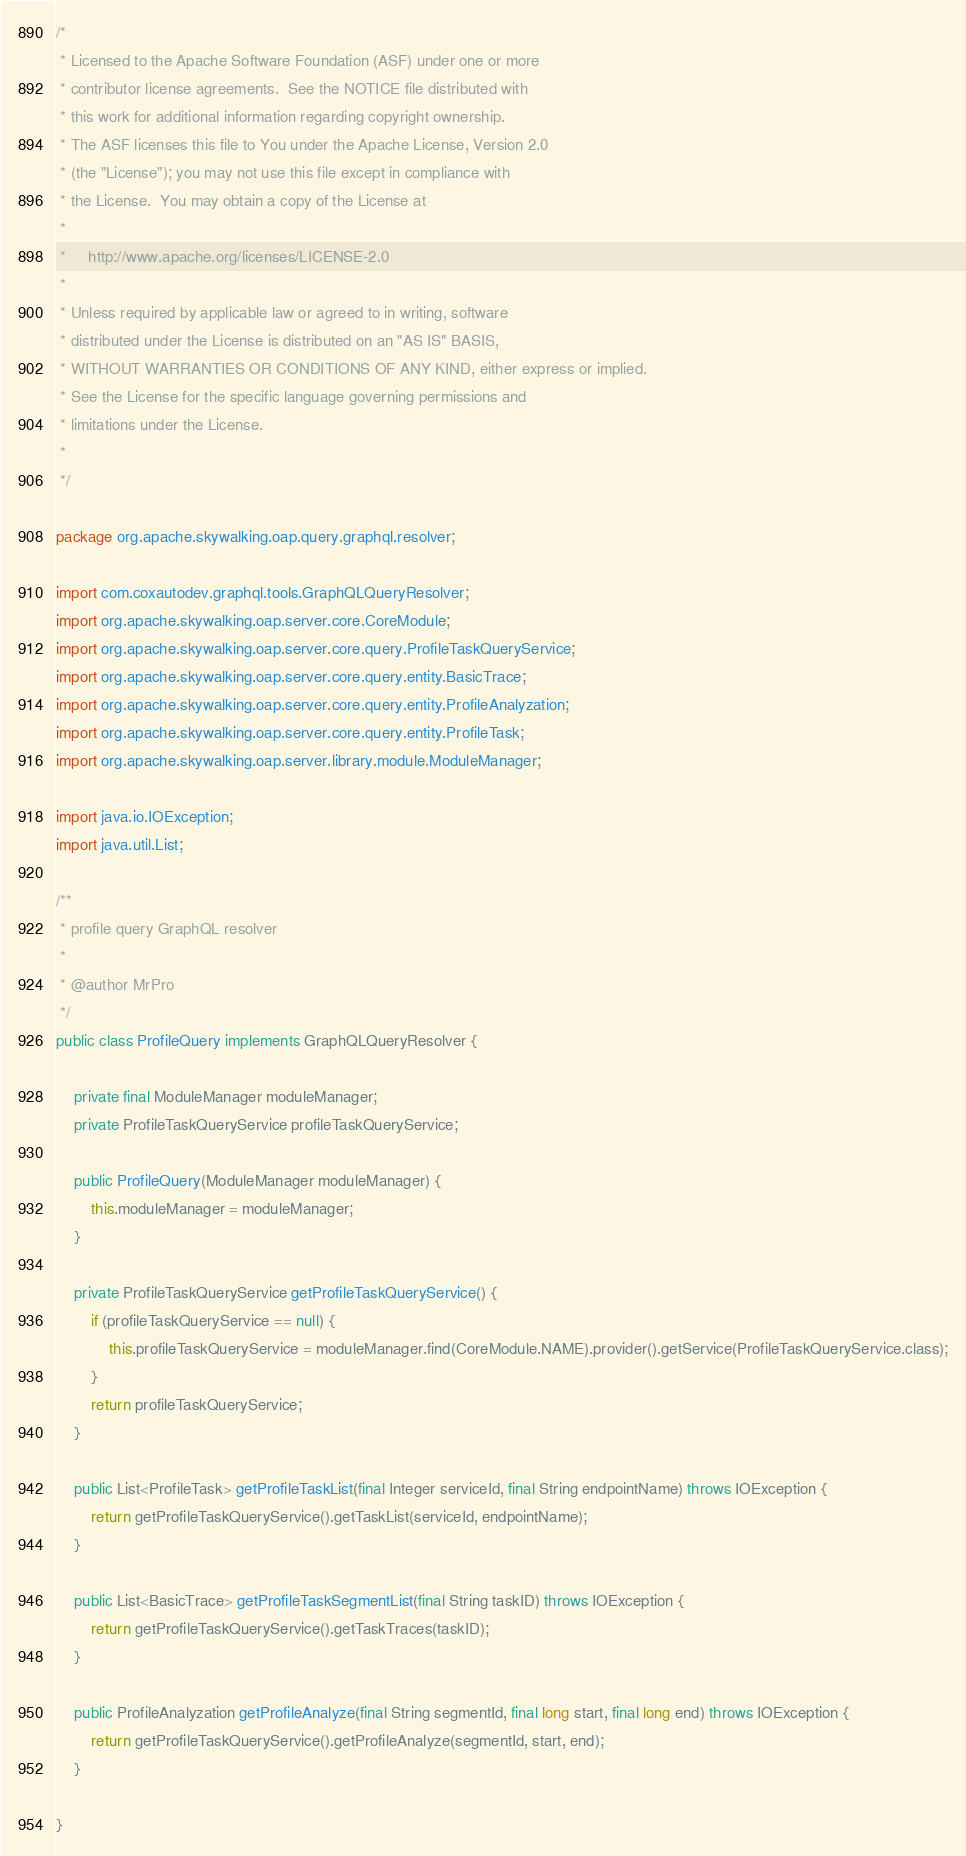Convert code to text. <code><loc_0><loc_0><loc_500><loc_500><_Java_>/*
 * Licensed to the Apache Software Foundation (ASF) under one or more
 * contributor license agreements.  See the NOTICE file distributed with
 * this work for additional information regarding copyright ownership.
 * The ASF licenses this file to You under the Apache License, Version 2.0
 * (the "License"); you may not use this file except in compliance with
 * the License.  You may obtain a copy of the License at
 *
 *     http://www.apache.org/licenses/LICENSE-2.0
 *
 * Unless required by applicable law or agreed to in writing, software
 * distributed under the License is distributed on an "AS IS" BASIS,
 * WITHOUT WARRANTIES OR CONDITIONS OF ANY KIND, either express or implied.
 * See the License for the specific language governing permissions and
 * limitations under the License.
 *
 */

package org.apache.skywalking.oap.query.graphql.resolver;

import com.coxautodev.graphql.tools.GraphQLQueryResolver;
import org.apache.skywalking.oap.server.core.CoreModule;
import org.apache.skywalking.oap.server.core.query.ProfileTaskQueryService;
import org.apache.skywalking.oap.server.core.query.entity.BasicTrace;
import org.apache.skywalking.oap.server.core.query.entity.ProfileAnalyzation;
import org.apache.skywalking.oap.server.core.query.entity.ProfileTask;
import org.apache.skywalking.oap.server.library.module.ModuleManager;

import java.io.IOException;
import java.util.List;

/**
 * profile query GraphQL resolver
 *
 * @author MrPro
 */
public class ProfileQuery implements GraphQLQueryResolver {

    private final ModuleManager moduleManager;
    private ProfileTaskQueryService profileTaskQueryService;

    public ProfileQuery(ModuleManager moduleManager) {
        this.moduleManager = moduleManager;
    }

    private ProfileTaskQueryService getProfileTaskQueryService() {
        if (profileTaskQueryService == null) {
            this.profileTaskQueryService = moduleManager.find(CoreModule.NAME).provider().getService(ProfileTaskQueryService.class);
        }
        return profileTaskQueryService;
    }

    public List<ProfileTask> getProfileTaskList(final Integer serviceId, final String endpointName) throws IOException {
        return getProfileTaskQueryService().getTaskList(serviceId, endpointName);
    }

    public List<BasicTrace> getProfileTaskSegmentList(final String taskID) throws IOException {
        return getProfileTaskQueryService().getTaskTraces(taskID);
    }

    public ProfileAnalyzation getProfileAnalyze(final String segmentId, final long start, final long end) throws IOException {
        return getProfileTaskQueryService().getProfileAnalyze(segmentId, start, end);
    }

}
</code> 